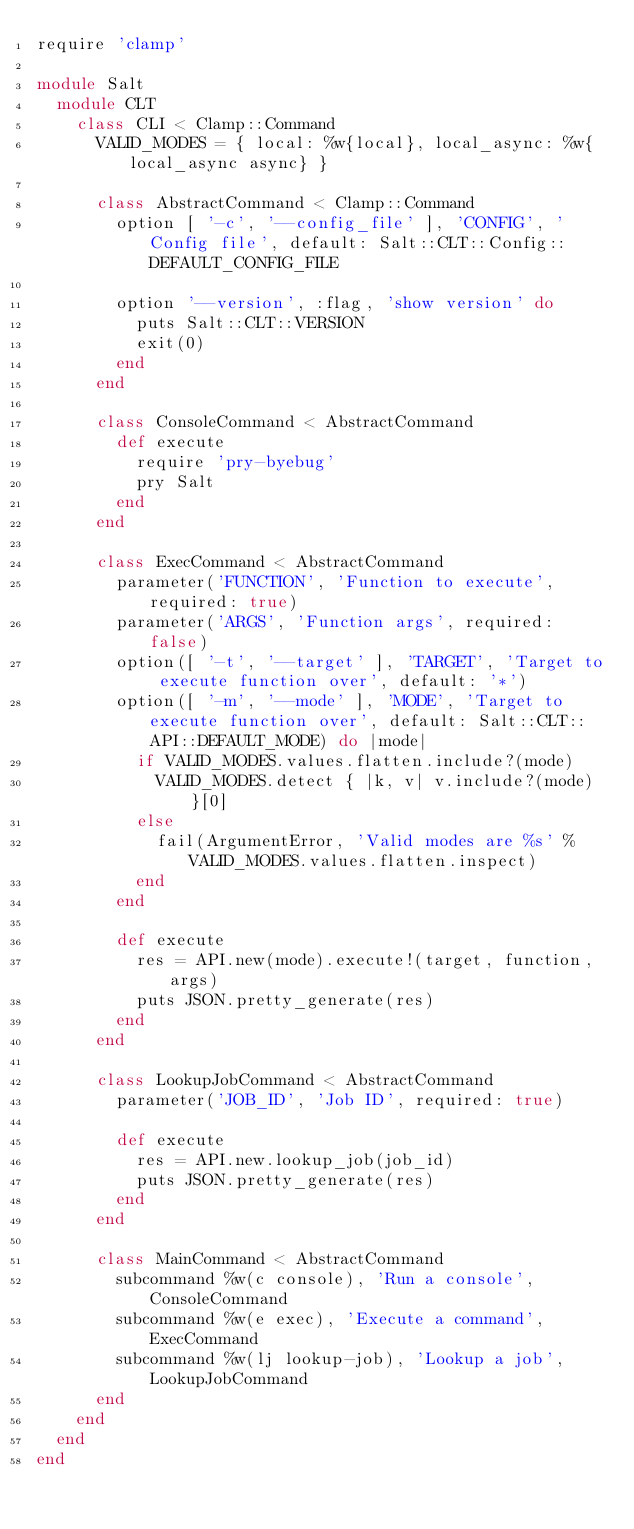<code> <loc_0><loc_0><loc_500><loc_500><_Ruby_>require 'clamp'

module Salt
  module CLT
    class CLI < Clamp::Command
      VALID_MODES = { local: %w{local}, local_async: %w{local_async async} }

      class AbstractCommand < Clamp::Command
        option [ '-c', '--config_file' ], 'CONFIG', 'Config file', default: Salt::CLT::Config::DEFAULT_CONFIG_FILE

        option '--version', :flag, 'show version' do
          puts Salt::CLT::VERSION
          exit(0)
        end
      end

      class ConsoleCommand < AbstractCommand
        def execute
          require 'pry-byebug'
          pry Salt
        end
      end

      class ExecCommand < AbstractCommand
        parameter('FUNCTION', 'Function to execute', required: true)
        parameter('ARGS', 'Function args', required: false)
        option([ '-t', '--target' ], 'TARGET', 'Target to execute function over', default: '*')
        option([ '-m', '--mode' ], 'MODE', 'Target to execute function over', default: Salt::CLT::API::DEFAULT_MODE) do |mode|
          if VALID_MODES.values.flatten.include?(mode)
            VALID_MODES.detect { |k, v| v.include?(mode) }[0]
          else
            fail(ArgumentError, 'Valid modes are %s' % VALID_MODES.values.flatten.inspect)
          end
        end

        def execute
          res = API.new(mode).execute!(target, function, args)
          puts JSON.pretty_generate(res)
        end
      end

      class LookupJobCommand < AbstractCommand
        parameter('JOB_ID', 'Job ID', required: true)

        def execute
          res = API.new.lookup_job(job_id)
          puts JSON.pretty_generate(res)
        end
      end

      class MainCommand < AbstractCommand
        subcommand %w(c console), 'Run a console', ConsoleCommand
        subcommand %w(e exec), 'Execute a command', ExecCommand
        subcommand %w(lj lookup-job), 'Lookup a job', LookupJobCommand
      end
    end
  end
end
</code> 